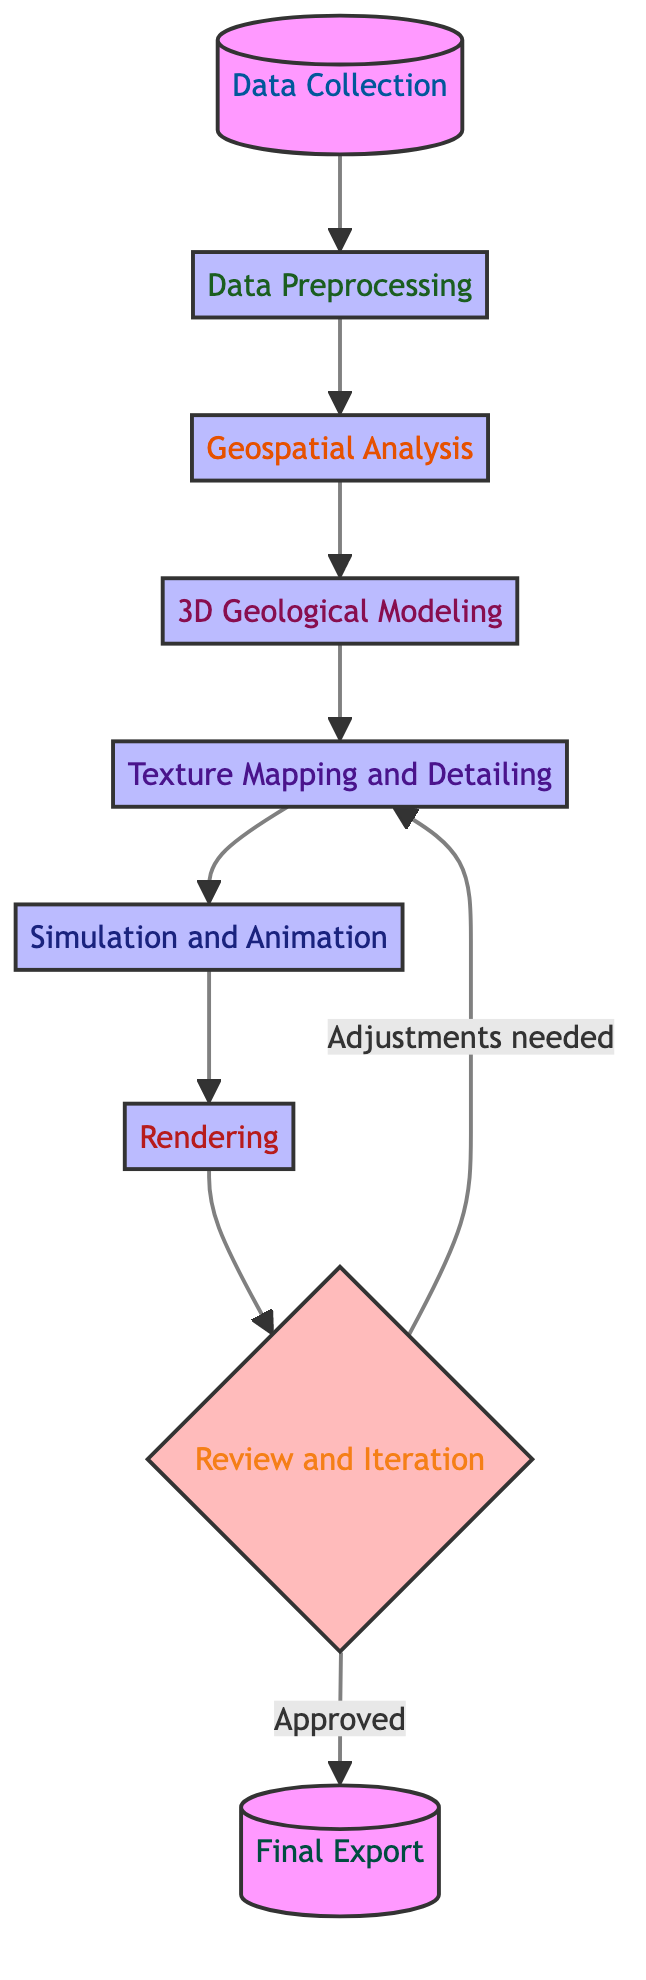What is the first step in the workflow? The first step in the workflow indicates the start of the process. In this diagram, the first node is labeled "Data Collection."
Answer: Data Collection How many total steps are presented in the workflow? The diagram has a total of nine distinct steps represented by nodes, including both processes and the final export.
Answer: Nine What step comes after "Geospatial Analysis"? Following the flow from "Geospatial Analysis," the next step in the sequence is "3D Geological Modeling." This is indicated by the arrow leading to the next node.
Answer: 3D Geological Modeling Which step requires iteration based on the diagram? The step "Review and Iteration" indicates that adjustments may lead back to "Texture Mapping and Detailing," indicating a need for iteration.
Answer: Review and Iteration What are the two possible outcomes after "Review and Iteration"? The outcomes shown are defined by the two arrows leading from "Review and Iteration," which state "Adjustments needed" leading back to "Texture Mapping and Detailing," and "Approved" leading to "Final Export."
Answer: Adjustments needed and Approved What is the main purpose of the "Simulation and Animation" step? The purpose is indicated within the node, which mentions integrating dynamic elements like water flow and erosion, crucial for realistic animations in geological contexts.
Answer: To integrate dynamic elements Identify the node that applies textures and details. The node titled "Texture Mapping and Detailing" explicitly states its purpose, which is to enhance the realism of the 3D model.
Answer: Texture Mapping and Detailing What type of tools are used in the "Geospatial Analysis" step? The diagram specifies the use of Geographic Information Systems (GIS) tools for this analytical step, emphasizing its importance in evaluating spatial data.
Answer: Geographic Information Systems (GIS) tools Which step utilizes high-performance computing for its process? The "Rendering" step leverages high-performance computing or cloud services to achieve the quality needed for final 3D scenes, as stated in its description.
Answer: Rendering 